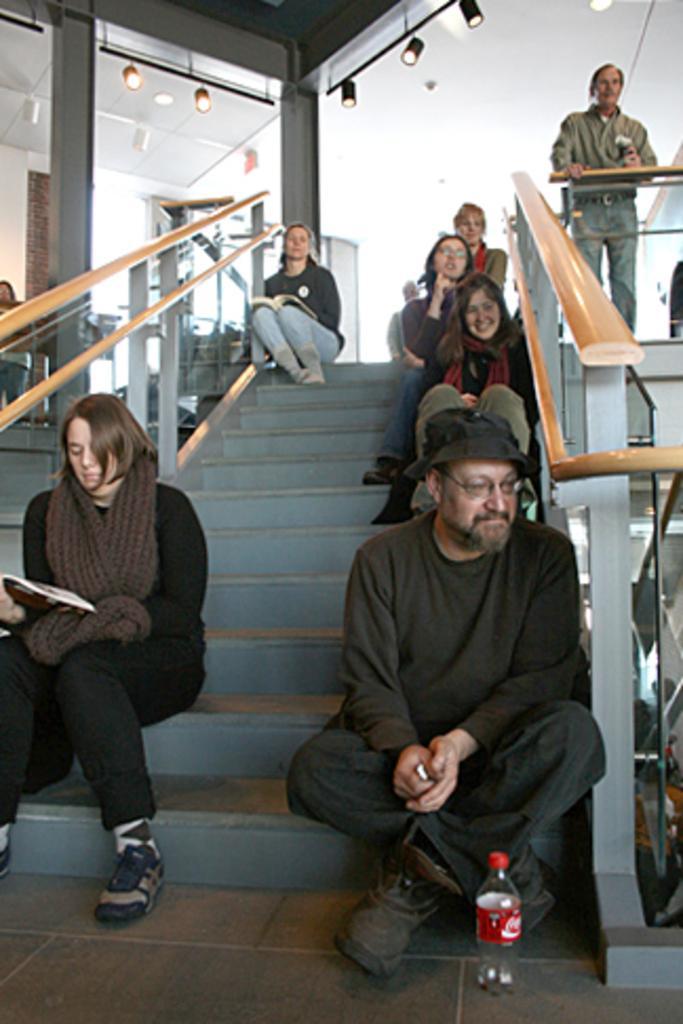Can you describe this image briefly? In the center of the image, we can see people sitting on the stairs and on the right, there is a person standing. In the background, there are lights and there is a wall. 